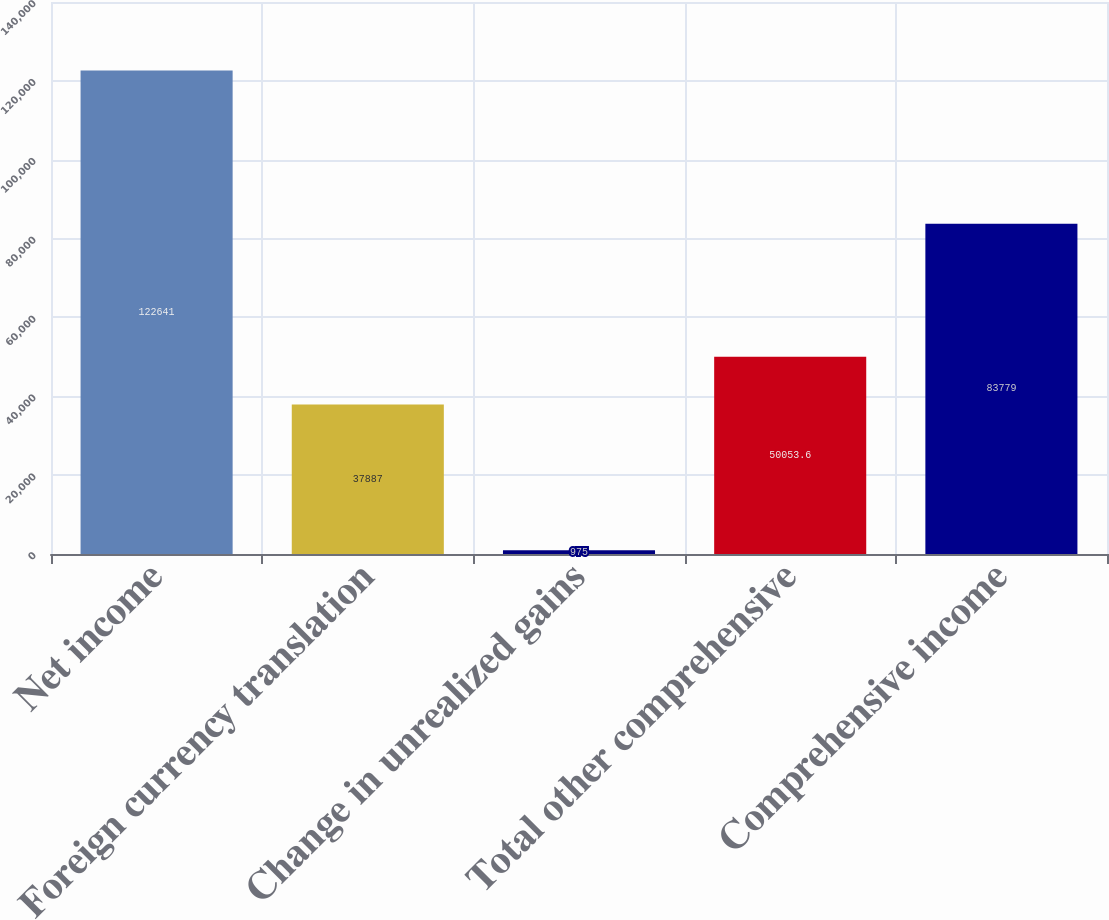Convert chart. <chart><loc_0><loc_0><loc_500><loc_500><bar_chart><fcel>Net income<fcel>Foreign currency translation<fcel>Change in unrealized gains<fcel>Total other comprehensive<fcel>Comprehensive income<nl><fcel>122641<fcel>37887<fcel>975<fcel>50053.6<fcel>83779<nl></chart> 